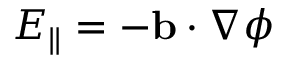<formula> <loc_0><loc_0><loc_500><loc_500>E _ { \| } = - b \cdot \nabla \phi</formula> 